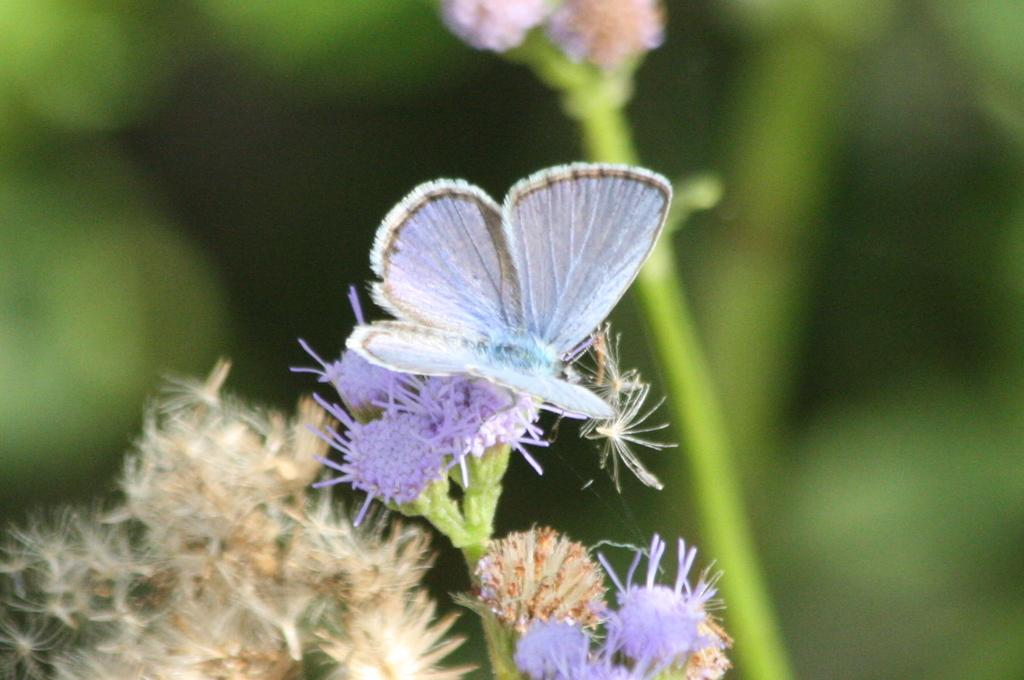What is the main subject of the image? There is a small butterfly on a flower in the image. Can you describe the flower in the image? The flower has a stem and is in the background of the image. What type of screw can be seen holding the star to the toy in the image? There is no screw, star, or toy present in the image; it features a butterfly on a flower. 